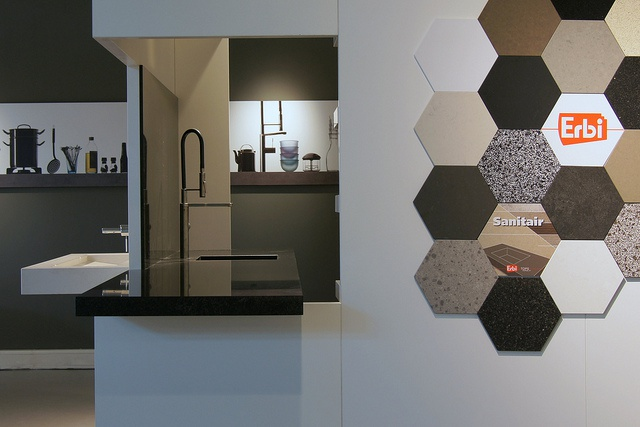Describe the objects in this image and their specific colors. I can see sink in black, darkgray, and gray tones, sink in black and gray tones, bottle in black, olive, and gray tones, bowl in black, darkgray, and gray tones, and spoon in black, gray, and darkgreen tones in this image. 